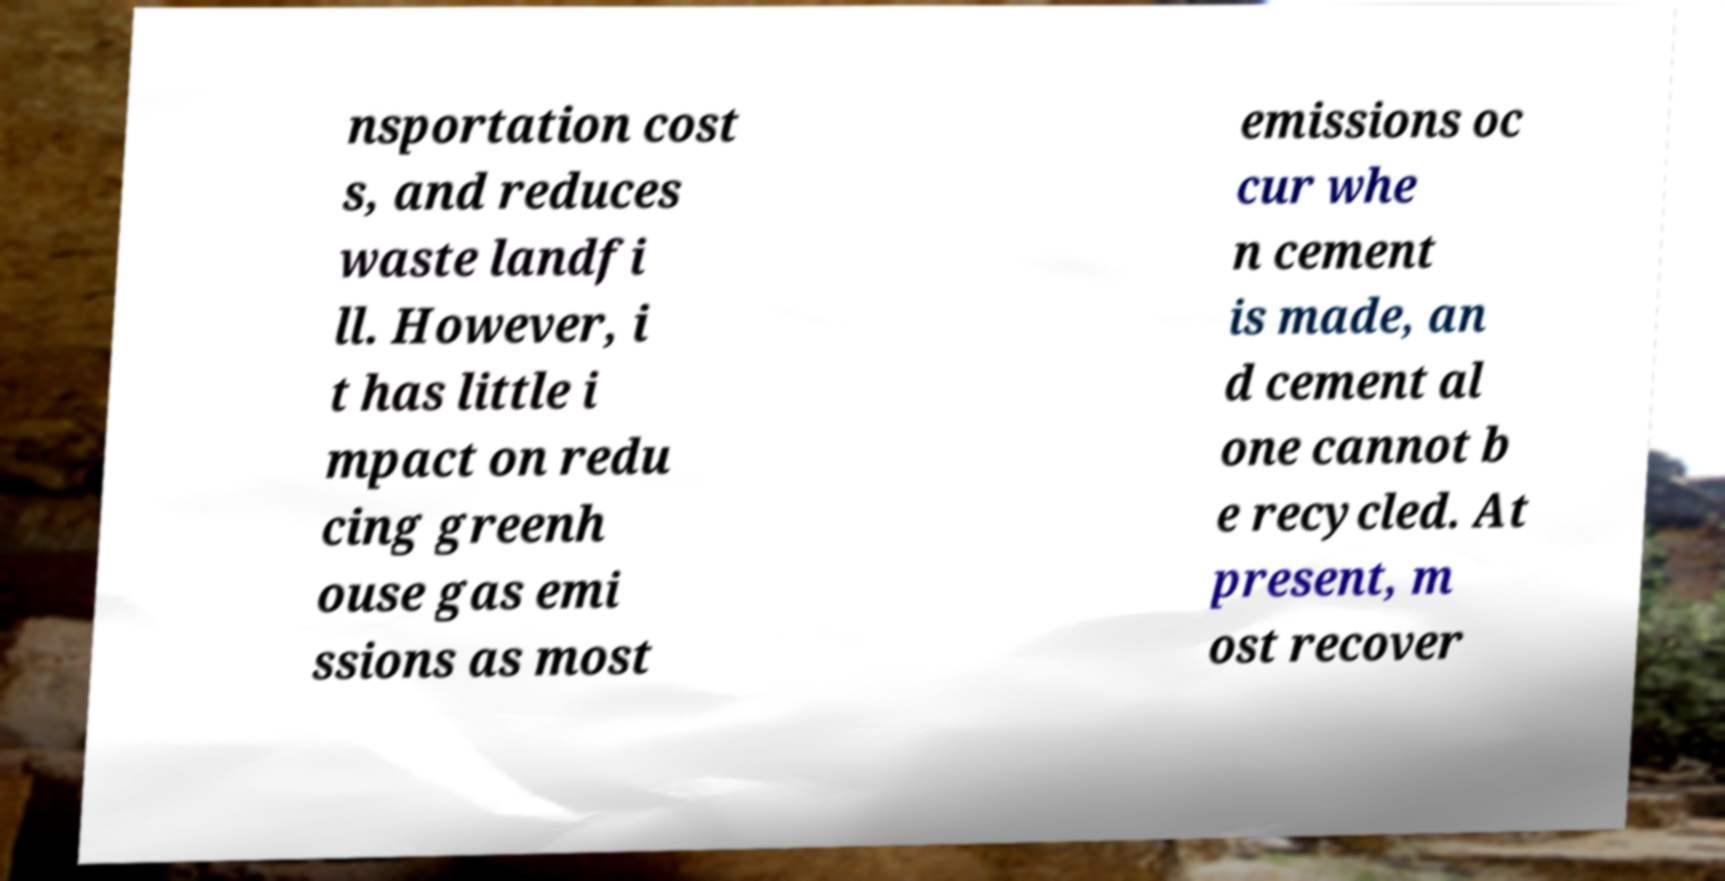I need the written content from this picture converted into text. Can you do that? nsportation cost s, and reduces waste landfi ll. However, i t has little i mpact on redu cing greenh ouse gas emi ssions as most emissions oc cur whe n cement is made, an d cement al one cannot b e recycled. At present, m ost recover 